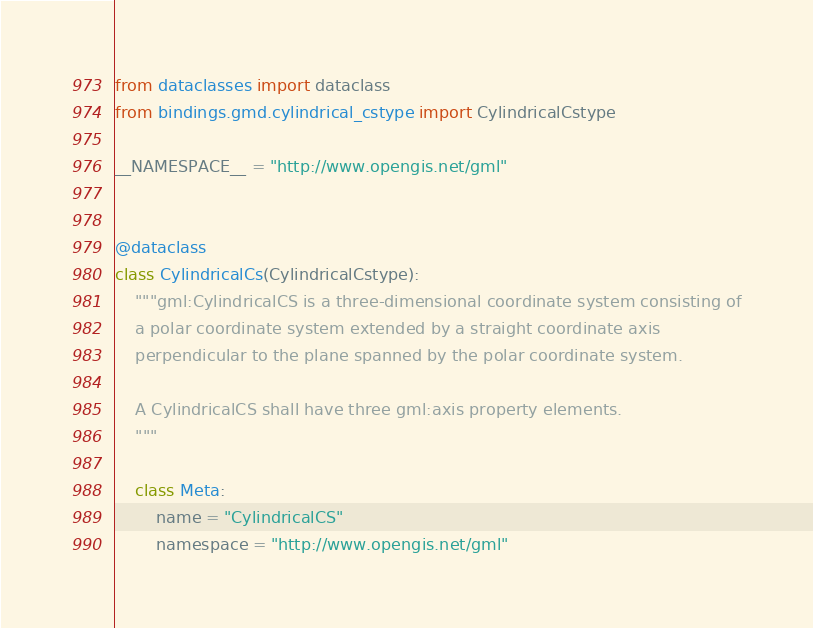<code> <loc_0><loc_0><loc_500><loc_500><_Python_>from dataclasses import dataclass
from bindings.gmd.cylindrical_cstype import CylindricalCstype

__NAMESPACE__ = "http://www.opengis.net/gml"


@dataclass
class CylindricalCs(CylindricalCstype):
    """gml:CylindricalCS is a three-dimensional coordinate system consisting of
    a polar coordinate system extended by a straight coordinate axis
    perpendicular to the plane spanned by the polar coordinate system.

    A CylindricalCS shall have three gml:axis property elements.
    """

    class Meta:
        name = "CylindricalCS"
        namespace = "http://www.opengis.net/gml"
</code> 